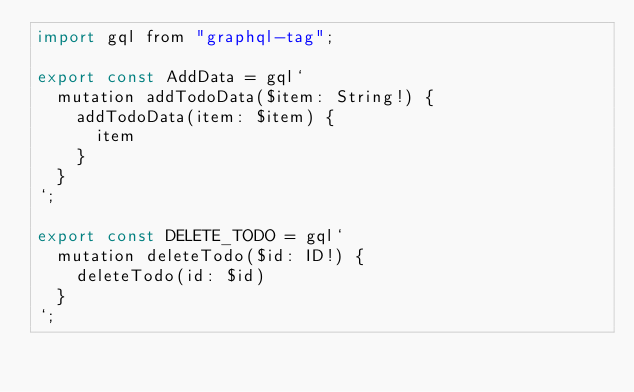<code> <loc_0><loc_0><loc_500><loc_500><_JavaScript_>import gql from "graphql-tag";

export const AddData = gql`
  mutation addTodoData($item: String!) {
    addTodoData(item: $item) {
      item
    }
  }
`;

export const DELETE_TODO = gql`
  mutation deleteTodo($id: ID!) {
    deleteTodo(id: $id)
  }
`;
</code> 